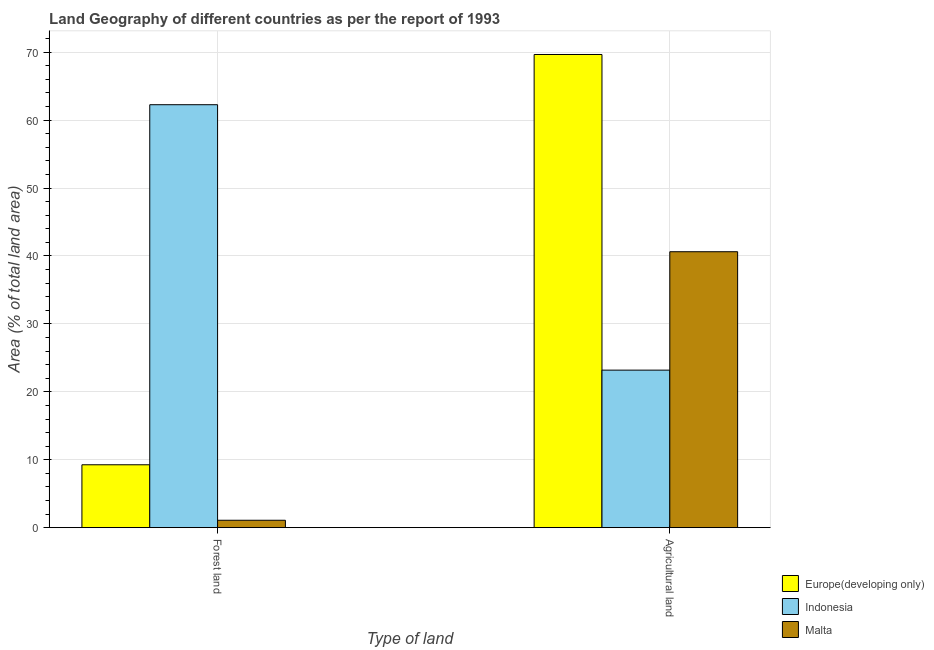How many different coloured bars are there?
Your answer should be compact. 3. How many groups of bars are there?
Give a very brief answer. 2. Are the number of bars per tick equal to the number of legend labels?
Offer a very short reply. Yes. Are the number of bars on each tick of the X-axis equal?
Provide a succinct answer. Yes. How many bars are there on the 2nd tick from the right?
Give a very brief answer. 3. What is the label of the 2nd group of bars from the left?
Provide a succinct answer. Agricultural land. What is the percentage of land area under forests in Indonesia?
Provide a succinct answer. 62.27. Across all countries, what is the maximum percentage of land area under forests?
Your response must be concise. 62.27. Across all countries, what is the minimum percentage of land area under forests?
Ensure brevity in your answer.  1.09. In which country was the percentage of land area under agriculture maximum?
Your answer should be very brief. Europe(developing only). In which country was the percentage of land area under agriculture minimum?
Your answer should be compact. Indonesia. What is the total percentage of land area under agriculture in the graph?
Provide a short and direct response. 133.48. What is the difference between the percentage of land area under forests in Malta and that in Indonesia?
Your response must be concise. -61.18. What is the difference between the percentage of land area under forests in Indonesia and the percentage of land area under agriculture in Malta?
Your answer should be very brief. 21.64. What is the average percentage of land area under agriculture per country?
Your answer should be compact. 44.49. What is the difference between the percentage of land area under forests and percentage of land area under agriculture in Indonesia?
Give a very brief answer. 39.08. What is the ratio of the percentage of land area under agriculture in Europe(developing only) to that in Malta?
Provide a short and direct response. 1.71. What does the 2nd bar from the left in Agricultural land represents?
Offer a very short reply. Indonesia. What does the 1st bar from the right in Forest land represents?
Your answer should be compact. Malta. Are all the bars in the graph horizontal?
Your answer should be very brief. No. Are the values on the major ticks of Y-axis written in scientific E-notation?
Make the answer very short. No. What is the title of the graph?
Make the answer very short. Land Geography of different countries as per the report of 1993. Does "Central African Republic" appear as one of the legend labels in the graph?
Make the answer very short. No. What is the label or title of the X-axis?
Ensure brevity in your answer.  Type of land. What is the label or title of the Y-axis?
Your response must be concise. Area (% of total land area). What is the Area (% of total land area) of Europe(developing only) in Forest land?
Your answer should be very brief. 9.26. What is the Area (% of total land area) in Indonesia in Forest land?
Offer a terse response. 62.27. What is the Area (% of total land area) of Malta in Forest land?
Provide a short and direct response. 1.09. What is the Area (% of total land area) in Europe(developing only) in Agricultural land?
Give a very brief answer. 69.66. What is the Area (% of total land area) in Indonesia in Agricultural land?
Ensure brevity in your answer.  23.19. What is the Area (% of total land area) in Malta in Agricultural land?
Provide a short and direct response. 40.62. Across all Type of land, what is the maximum Area (% of total land area) in Europe(developing only)?
Give a very brief answer. 69.66. Across all Type of land, what is the maximum Area (% of total land area) in Indonesia?
Your answer should be very brief. 62.27. Across all Type of land, what is the maximum Area (% of total land area) of Malta?
Give a very brief answer. 40.62. Across all Type of land, what is the minimum Area (% of total land area) of Europe(developing only)?
Your response must be concise. 9.26. Across all Type of land, what is the minimum Area (% of total land area) in Indonesia?
Provide a succinct answer. 23.19. Across all Type of land, what is the minimum Area (% of total land area) in Malta?
Make the answer very short. 1.09. What is the total Area (% of total land area) in Europe(developing only) in the graph?
Offer a terse response. 78.92. What is the total Area (% of total land area) of Indonesia in the graph?
Ensure brevity in your answer.  85.46. What is the total Area (% of total land area) of Malta in the graph?
Your answer should be compact. 41.72. What is the difference between the Area (% of total land area) in Europe(developing only) in Forest land and that in Agricultural land?
Provide a short and direct response. -60.4. What is the difference between the Area (% of total land area) of Indonesia in Forest land and that in Agricultural land?
Provide a succinct answer. 39.08. What is the difference between the Area (% of total land area) in Malta in Forest land and that in Agricultural land?
Offer a terse response. -39.53. What is the difference between the Area (% of total land area) in Europe(developing only) in Forest land and the Area (% of total land area) in Indonesia in Agricultural land?
Your response must be concise. -13.93. What is the difference between the Area (% of total land area) in Europe(developing only) in Forest land and the Area (% of total land area) in Malta in Agricultural land?
Provide a succinct answer. -31.36. What is the difference between the Area (% of total land area) of Indonesia in Forest land and the Area (% of total land area) of Malta in Agricultural land?
Your answer should be very brief. 21.64. What is the average Area (% of total land area) in Europe(developing only) per Type of land?
Your answer should be very brief. 39.46. What is the average Area (% of total land area) in Indonesia per Type of land?
Make the answer very short. 42.73. What is the average Area (% of total land area) in Malta per Type of land?
Provide a succinct answer. 20.86. What is the difference between the Area (% of total land area) of Europe(developing only) and Area (% of total land area) of Indonesia in Forest land?
Ensure brevity in your answer.  -53.01. What is the difference between the Area (% of total land area) in Europe(developing only) and Area (% of total land area) in Malta in Forest land?
Your response must be concise. 8.17. What is the difference between the Area (% of total land area) of Indonesia and Area (% of total land area) of Malta in Forest land?
Provide a succinct answer. 61.17. What is the difference between the Area (% of total land area) of Europe(developing only) and Area (% of total land area) of Indonesia in Agricultural land?
Your answer should be compact. 46.47. What is the difference between the Area (% of total land area) of Europe(developing only) and Area (% of total land area) of Malta in Agricultural land?
Keep it short and to the point. 29.04. What is the difference between the Area (% of total land area) in Indonesia and Area (% of total land area) in Malta in Agricultural land?
Ensure brevity in your answer.  -17.43. What is the ratio of the Area (% of total land area) of Europe(developing only) in Forest land to that in Agricultural land?
Your answer should be very brief. 0.13. What is the ratio of the Area (% of total land area) in Indonesia in Forest land to that in Agricultural land?
Make the answer very short. 2.68. What is the ratio of the Area (% of total land area) of Malta in Forest land to that in Agricultural land?
Provide a short and direct response. 0.03. What is the difference between the highest and the second highest Area (% of total land area) of Europe(developing only)?
Your answer should be compact. 60.4. What is the difference between the highest and the second highest Area (% of total land area) in Indonesia?
Ensure brevity in your answer.  39.08. What is the difference between the highest and the second highest Area (% of total land area) of Malta?
Offer a very short reply. 39.53. What is the difference between the highest and the lowest Area (% of total land area) of Europe(developing only)?
Ensure brevity in your answer.  60.4. What is the difference between the highest and the lowest Area (% of total land area) in Indonesia?
Provide a short and direct response. 39.08. What is the difference between the highest and the lowest Area (% of total land area) in Malta?
Ensure brevity in your answer.  39.53. 